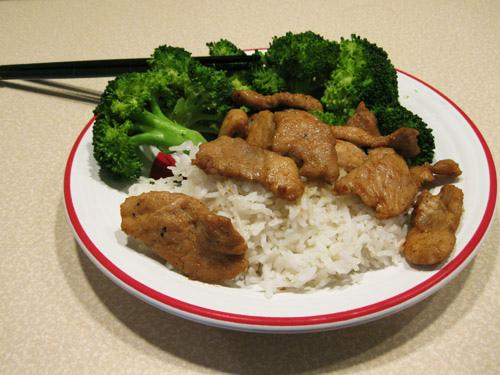Is this dish vegetarian friendly?
Keep it brief. No. Might this be a type of traditional Italian food?
Be succinct. No. Is the chicken cooked well?
Keep it brief. Yes. Is the meat chicken?
Quick response, please. Yes. What is under the chicken?
Short answer required. Rice. 